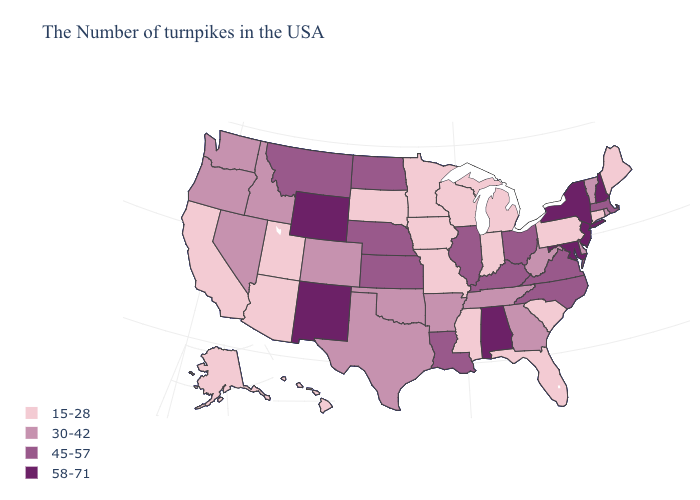Name the states that have a value in the range 30-42?
Short answer required. Rhode Island, Vermont, Delaware, West Virginia, Georgia, Tennessee, Arkansas, Oklahoma, Texas, Colorado, Idaho, Nevada, Washington, Oregon. What is the value of South Dakota?
Give a very brief answer. 15-28. Name the states that have a value in the range 45-57?
Concise answer only. Massachusetts, Virginia, North Carolina, Ohio, Kentucky, Illinois, Louisiana, Kansas, Nebraska, North Dakota, Montana. Which states hav the highest value in the MidWest?
Be succinct. Ohio, Illinois, Kansas, Nebraska, North Dakota. What is the value of Vermont?
Concise answer only. 30-42. Name the states that have a value in the range 15-28?
Be succinct. Maine, Connecticut, Pennsylvania, South Carolina, Florida, Michigan, Indiana, Wisconsin, Mississippi, Missouri, Minnesota, Iowa, South Dakota, Utah, Arizona, California, Alaska, Hawaii. What is the lowest value in the South?
Keep it brief. 15-28. Name the states that have a value in the range 30-42?
Be succinct. Rhode Island, Vermont, Delaware, West Virginia, Georgia, Tennessee, Arkansas, Oklahoma, Texas, Colorado, Idaho, Nevada, Washington, Oregon. Among the states that border Washington , which have the highest value?
Quick response, please. Idaho, Oregon. Is the legend a continuous bar?
Give a very brief answer. No. What is the lowest value in states that border Tennessee?
Concise answer only. 15-28. What is the value of Maine?
Be succinct. 15-28. Does Massachusetts have a lower value than New Hampshire?
Concise answer only. Yes. Among the states that border Tennessee , which have the lowest value?
Short answer required. Mississippi, Missouri. What is the lowest value in states that border Georgia?
Write a very short answer. 15-28. 